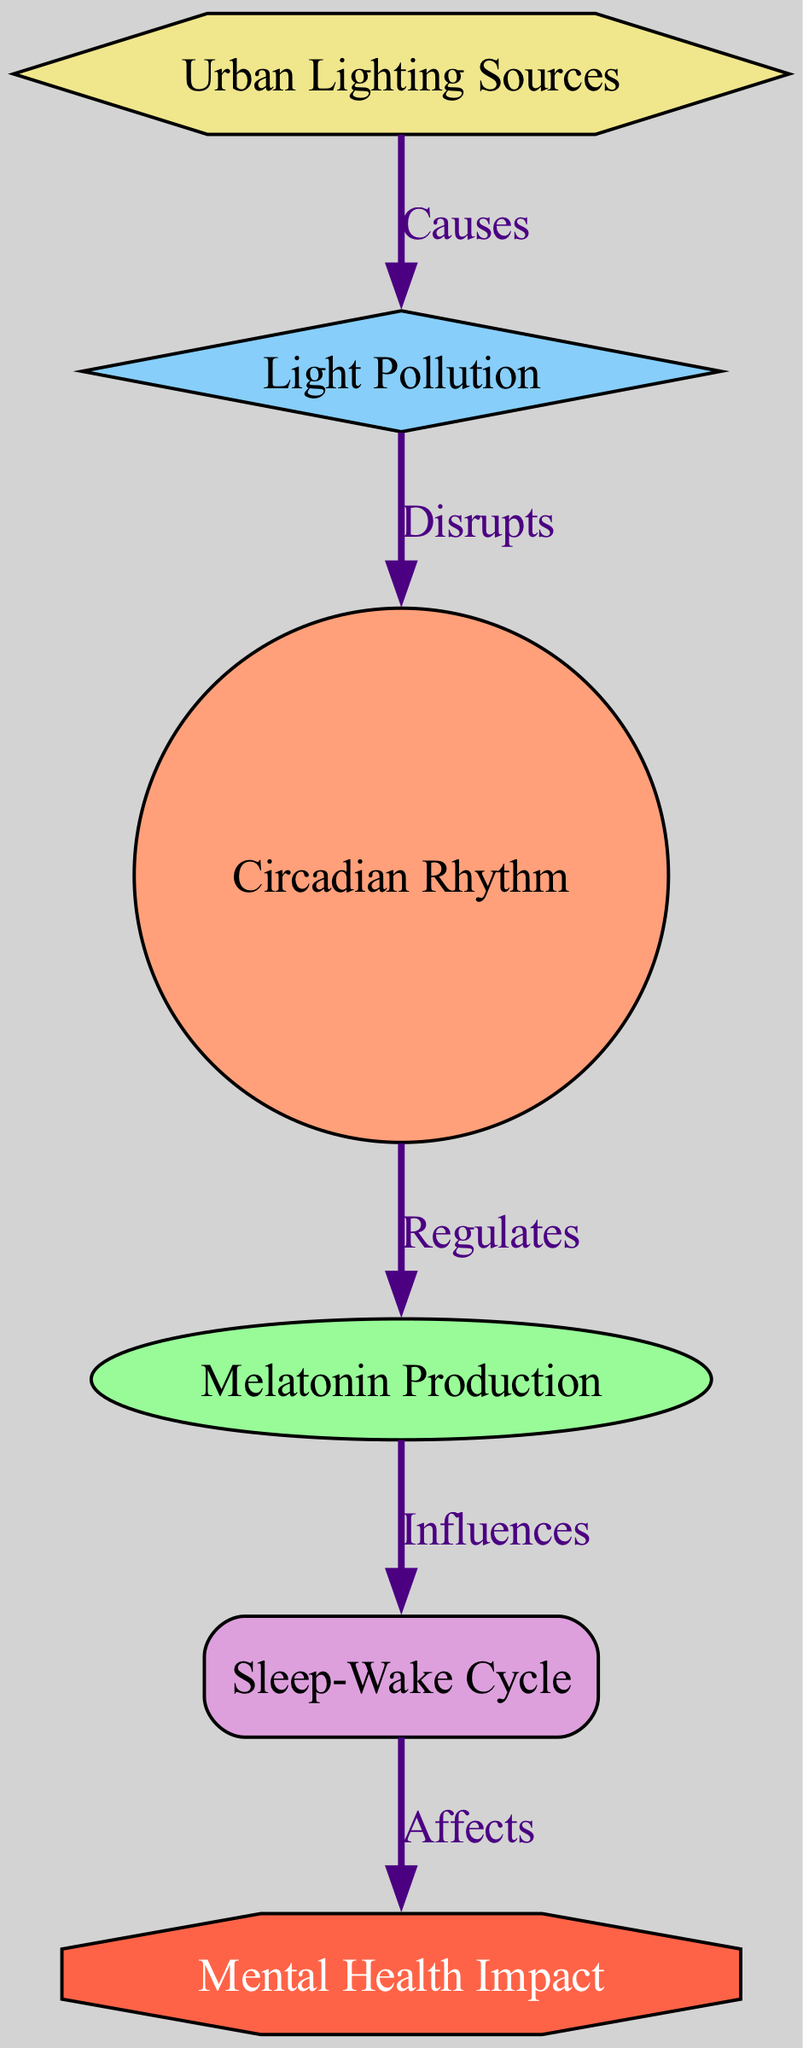What are the two main nodes that are directly connected by an edge? In the diagram, we can look for edges connecting nodes. The edges list includes various connections. By identifying two connected nodes, we focus on the edge relationships. The edge "Disrupts" links "Light Pollution" to "Circadian Rhythm."
Answer: Light Pollution, Circadian Rhythm How many nodes are present in the diagram? To determine the number of nodes, we can count the nodes listed in the data under "nodes." The list contains six distinct nodes.
Answer: 6 What effect does light pollution have on circadian rhythm? The edge labeled "Disrupts" shows the relationship directly from "Light Pollution" to "Circadian Rhythm." This indicates that light pollution disrupts the circadian rhythm.
Answer: Disrupts Which node is influenced by melatonin production? The diagram shows an edge labeled "Influences" going from "Melatonin Production" to "Sleep-Wake Cycle." Therefore, the node "Sleep-Wake Cycle" is influenced by melatonin production.
Answer: Sleep-Wake Cycle What is the relationship between sleep cycle and mental health? From the diagram, the edge connecting "Sleep-Wake Cycle" to "Mental Health Impact" is labeled "Affects." This indicates that the sleep cycle affects mental health.
Answer: Affects What causes light pollution in urban areas? According to the edges in the diagram, "Urban Lighting Sources" is linked to "Light Pollution" with the label "Causes." Hence, urban lighting sources are the cause of light pollution.
Answer: Urban Lighting Sources How many edges connect the nodes in this diagram? To find the total number of edges, we can count the edges listed in the "edges" section. There are five distinct edges connecting the nodes.
Answer: 5 What node increases melatonin production? The diagram does not explicitly provide a node that increases melatonin production, but it indicates that circadian rhythm regulates melatonin production. Therefore, we can infer that a stable circadian rhythm increases melatonin production.
Answer: Circadian Rhythm Which two factors relate to mental health impact in this diagram? The diagram shows that both "Sleep-Wake Cycle" and "Melatonin Production" indirectly influence "Mental Health Impact," forming a link but through different intermediary nodes. Therefore, those two factors are linked to mental health impact.
Answer: Sleep-Wake Cycle, Melatonin Production 